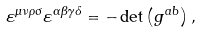Convert formula to latex. <formula><loc_0><loc_0><loc_500><loc_500>\varepsilon ^ { \mu \nu \rho \sigma } \varepsilon ^ { \alpha \beta \gamma \delta } = - \det \left ( g ^ { a b } \right ) ,</formula> 